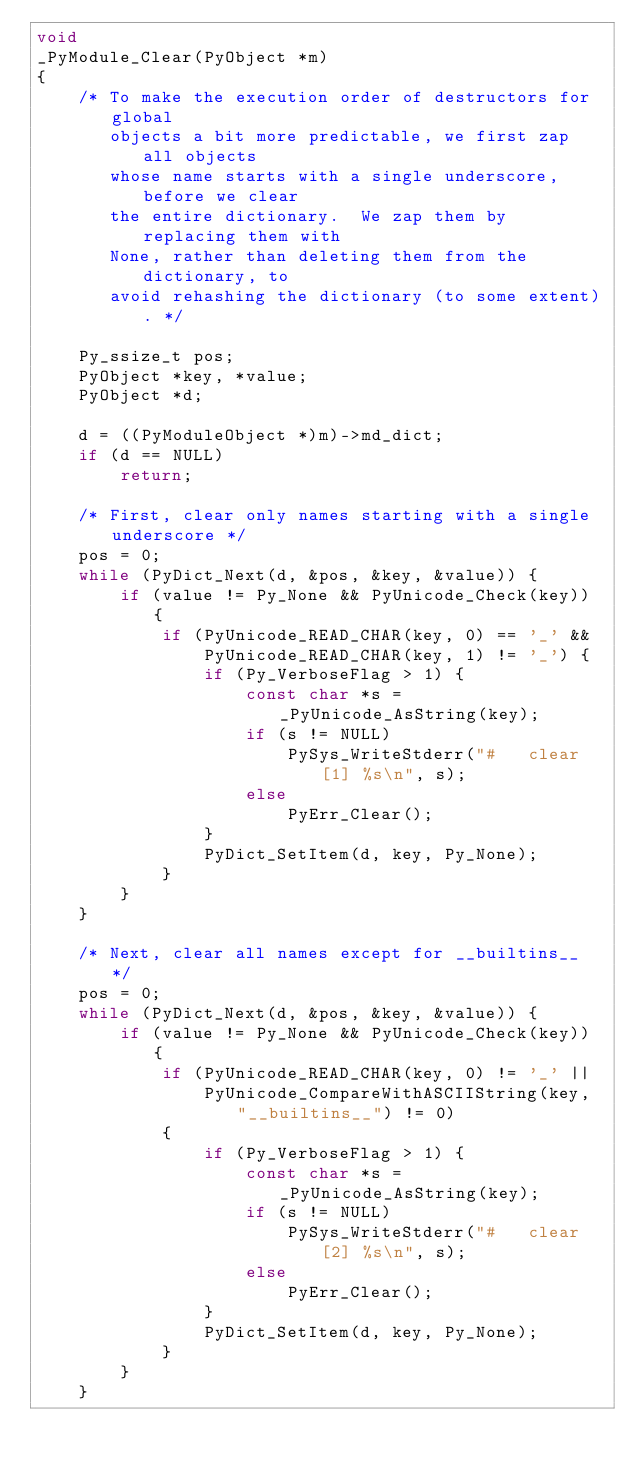<code> <loc_0><loc_0><loc_500><loc_500><_C_>void
_PyModule_Clear(PyObject *m)
{
    /* To make the execution order of destructors for global
       objects a bit more predictable, we first zap all objects
       whose name starts with a single underscore, before we clear
       the entire dictionary.  We zap them by replacing them with
       None, rather than deleting them from the dictionary, to
       avoid rehashing the dictionary (to some extent). */

    Py_ssize_t pos;
    PyObject *key, *value;
    PyObject *d;

    d = ((PyModuleObject *)m)->md_dict;
    if (d == NULL)
        return;

    /* First, clear only names starting with a single underscore */
    pos = 0;
    while (PyDict_Next(d, &pos, &key, &value)) {
        if (value != Py_None && PyUnicode_Check(key)) {
            if (PyUnicode_READ_CHAR(key, 0) == '_' &&
                PyUnicode_READ_CHAR(key, 1) != '_') {
                if (Py_VerboseFlag > 1) {
                    const char *s = _PyUnicode_AsString(key);
                    if (s != NULL)
                        PySys_WriteStderr("#   clear[1] %s\n", s);
                    else
                        PyErr_Clear();
                }
                PyDict_SetItem(d, key, Py_None);
            }
        }
    }

    /* Next, clear all names except for __builtins__ */
    pos = 0;
    while (PyDict_Next(d, &pos, &key, &value)) {
        if (value != Py_None && PyUnicode_Check(key)) {
            if (PyUnicode_READ_CHAR(key, 0) != '_' ||
                PyUnicode_CompareWithASCIIString(key, "__builtins__") != 0)
            {
                if (Py_VerboseFlag > 1) {
                    const char *s = _PyUnicode_AsString(key);
                    if (s != NULL)
                        PySys_WriteStderr("#   clear[2] %s\n", s);
                    else
                        PyErr_Clear();
                }
                PyDict_SetItem(d, key, Py_None);
            }
        }
    }
</code> 